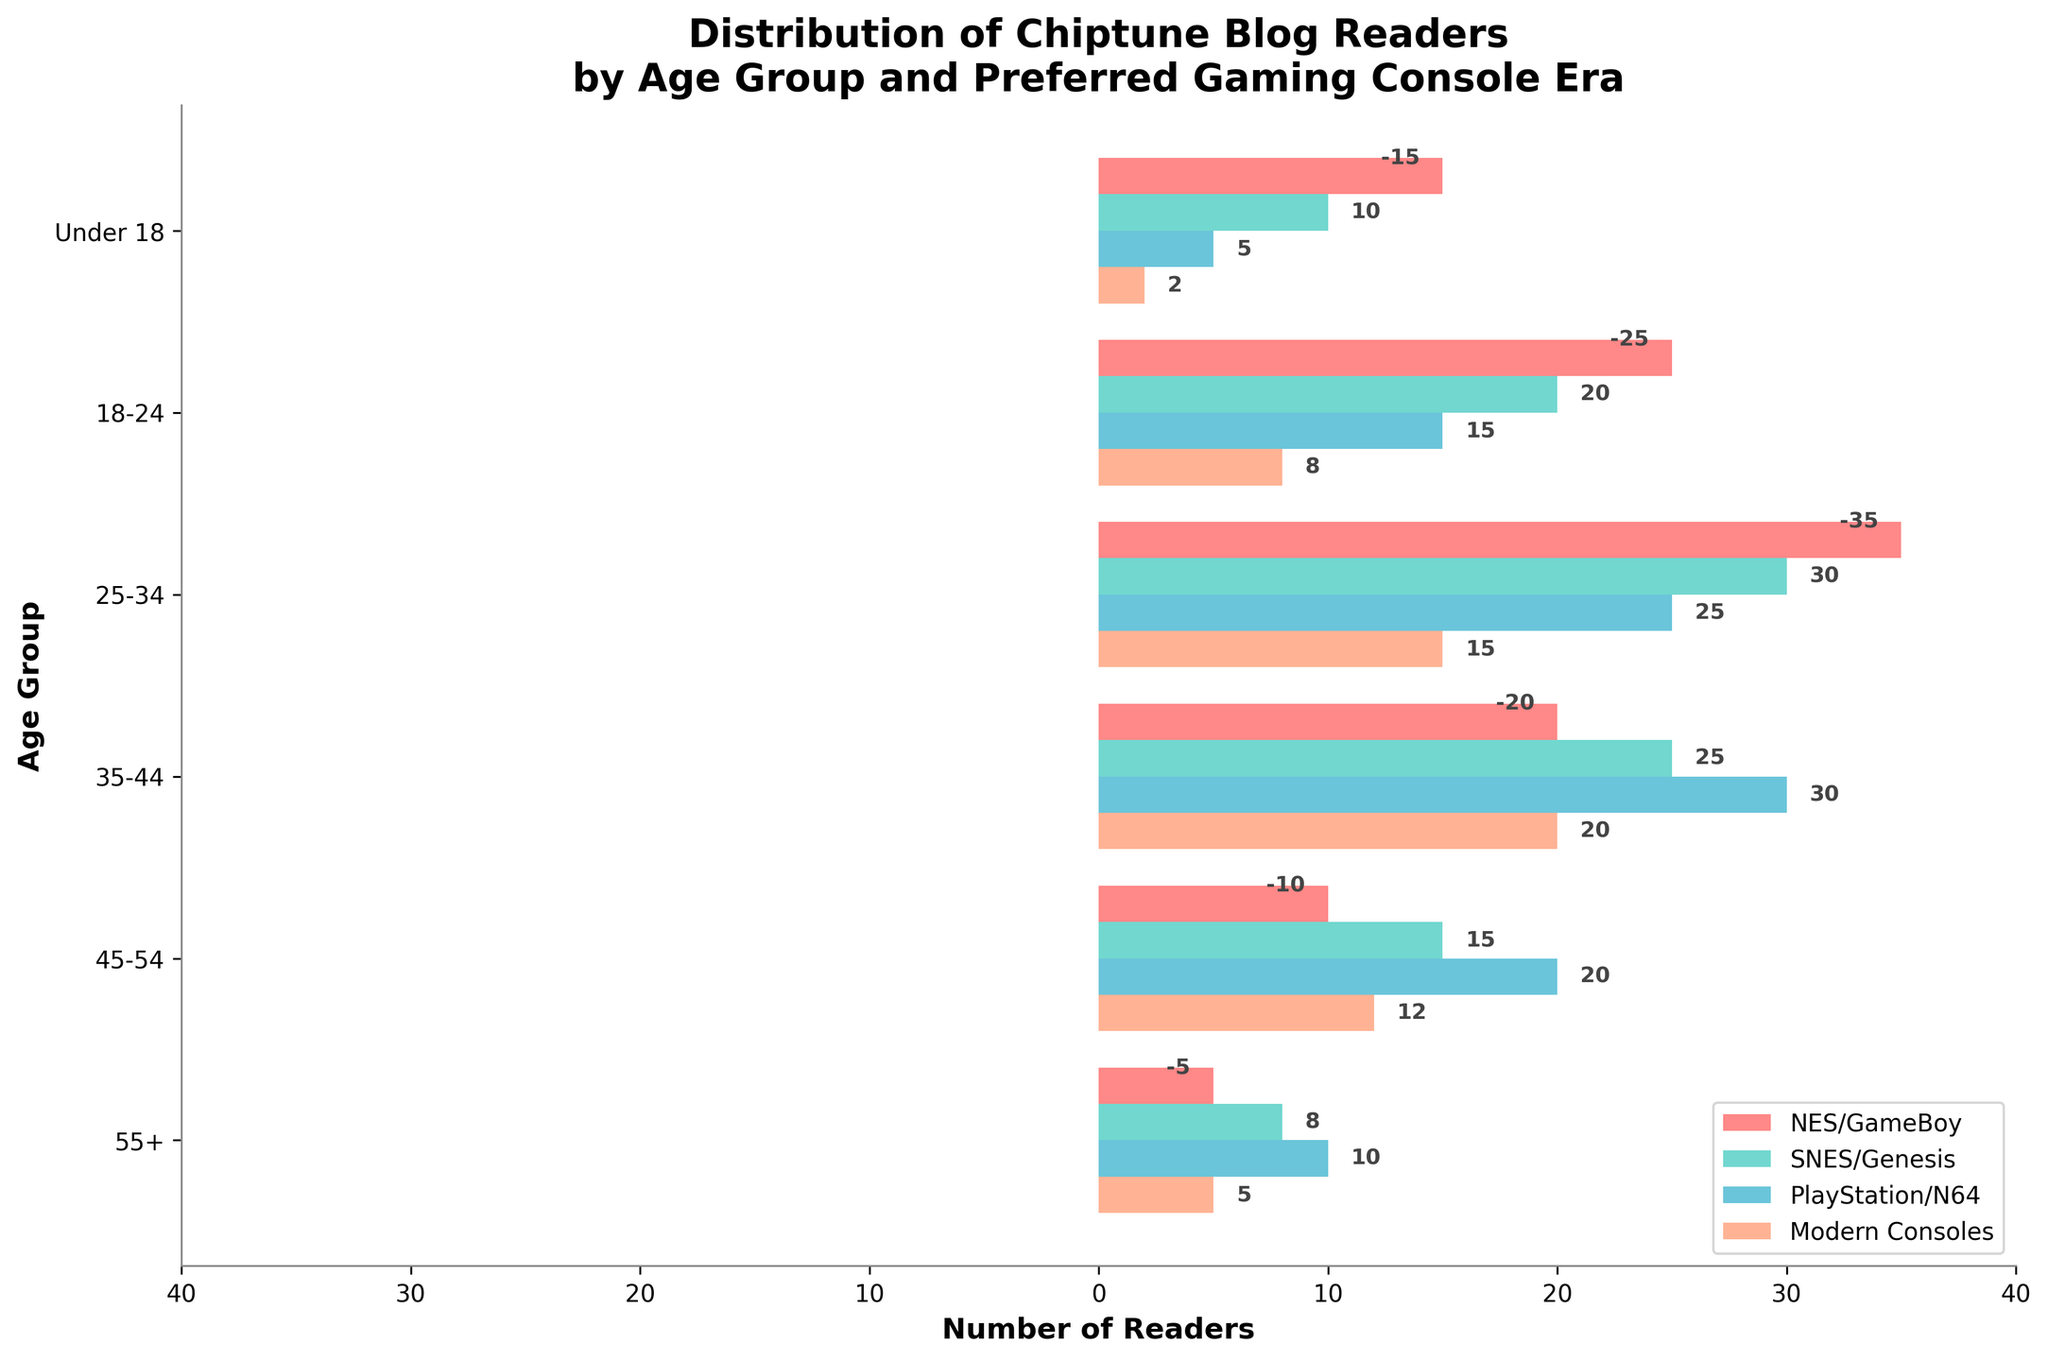How many age groups prefer the NES/GameBoy the most? Count the age groups where the NES/GameBoy bar extends further than the other bars.
Answer: 4 What is the age group with the highest number of readers preferring Modern Consoles? Identify the age group with the largest Modern Consoles bar.
Answer: 35-44 Which gaming console era is most popular among readers aged 25-34? Look at the bar lengths for the 25-34 age group and see which one extends the furthest.
Answer: PlayStation/N64 What is the total number of readers under 18 preferring NES/GameBoy and SNES/Genesis combined? Add the absolute values of the NES/GameBoy and SNES/Genesis bars for the Under 18 group.
Answer: 25 (15 from NES/GameBoy + 10 from SNES/Genesis) Are there more readers preferring SNES/Genesis or Modern Consoles in the 45-54 age group? Compare the lengths of the SNES/Genesis and Modern Consoles bars for the 45-54 age group.
Answer: SNES/Genesis Which age group has the least preference for any gaming console era? Compare the absolute values across all age groups for any era and identify the smallest bar.
Answer: Under 18 (Modern Consoles bar is 2) Do readers aged 35-44 show a strong preference toward any specific gaming console era? Assess the relative lengths of the bars for the 35-44 age group to determine if any bar is significantly longer.
Answer: PlayStation/N64 What is the combined total of readers aged 18-24 who prefer NES/GameBoy and PlayStation/N64? Add the absolute values of the NES/GameBoy and PlayStation/N64 bars for the 18-24 age group.
Answer: 40 (25 from NES/GameBoy + 15 from PlayStation/N64) Which age group shows the highest preference disparity between NES/GameBoy and Modern Consoles? Calculate the difference between the NES/GameBoy and Modern Consoles bars for each age group and identify the largest difference.
Answer: 25-34 